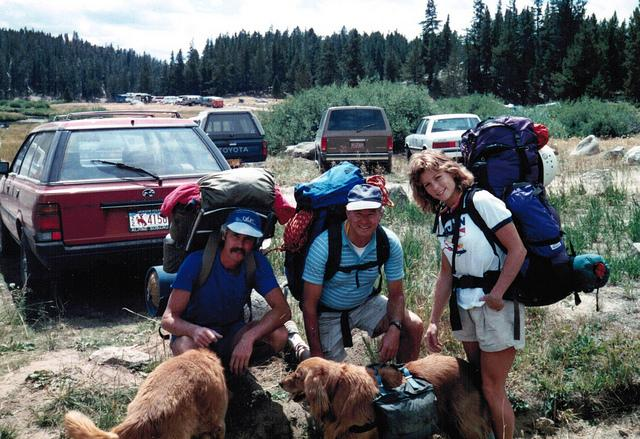What sort of adventure are they probably heading out on? Please explain your reasoning. camping. The adventure is camping. 